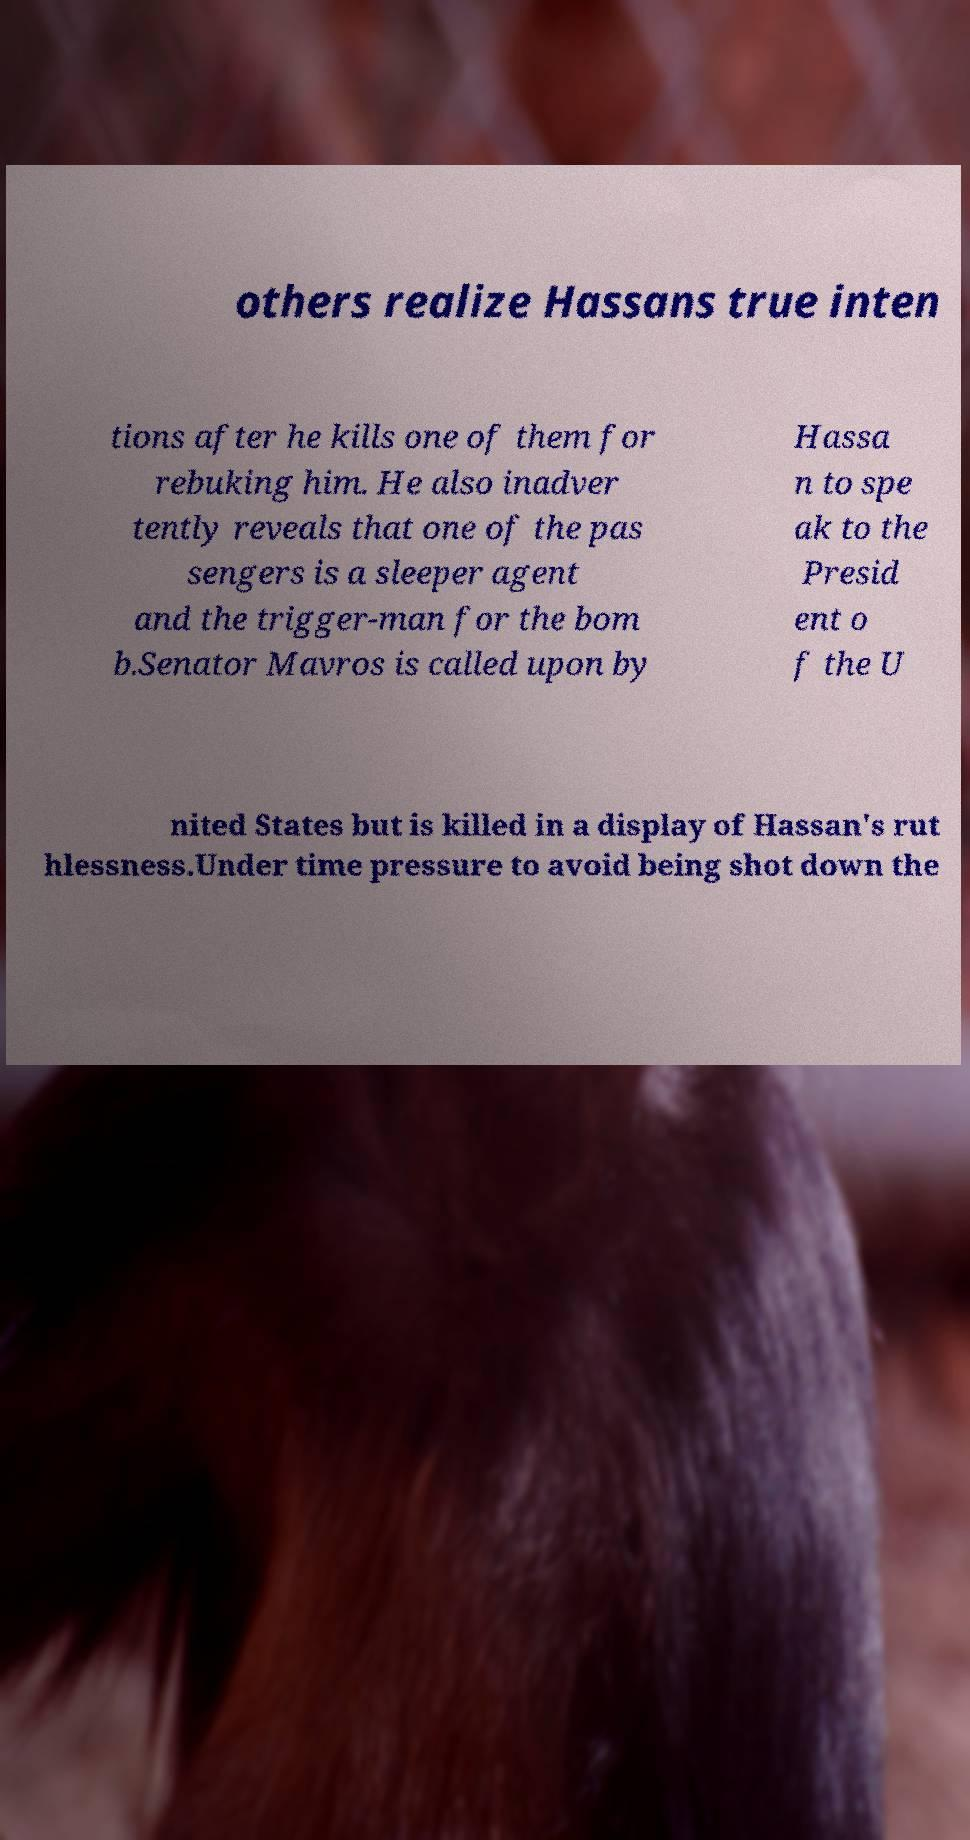Can you read and provide the text displayed in the image?This photo seems to have some interesting text. Can you extract and type it out for me? others realize Hassans true inten tions after he kills one of them for rebuking him. He also inadver tently reveals that one of the pas sengers is a sleeper agent and the trigger-man for the bom b.Senator Mavros is called upon by Hassa n to spe ak to the Presid ent o f the U nited States but is killed in a display of Hassan's rut hlessness.Under time pressure to avoid being shot down the 